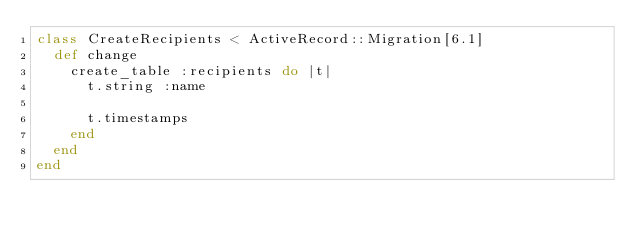Convert code to text. <code><loc_0><loc_0><loc_500><loc_500><_Ruby_>class CreateRecipients < ActiveRecord::Migration[6.1]
  def change
    create_table :recipients do |t|
      t.string :name

      t.timestamps
    end
  end
end
</code> 